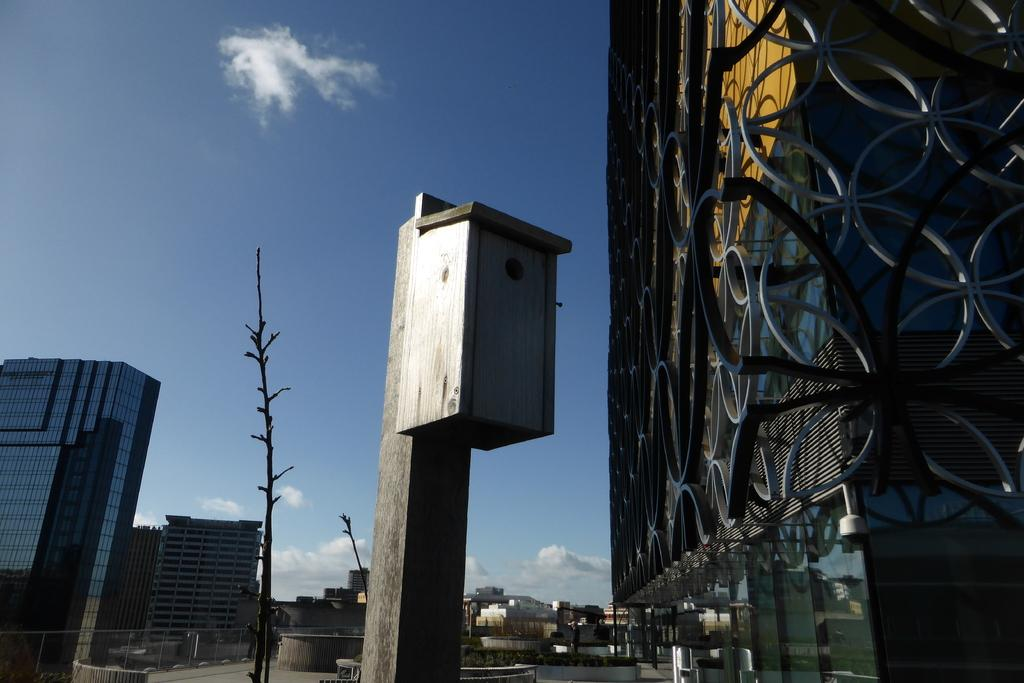What type of structure is present in the image? There is a building in the image. What object is attached to the pole in the image? There is a box attached to the pole in the image. What type of vegetation is present in the image? There is a tree in the image. What can be seen in the background of the image? There are other buildings visible in the background, and the sky is also visible. What type of grain is being transported by the bells in the image? There are no bells or grain present in the image. How does the transport system work in the image? There is no transport system visible in the image. 